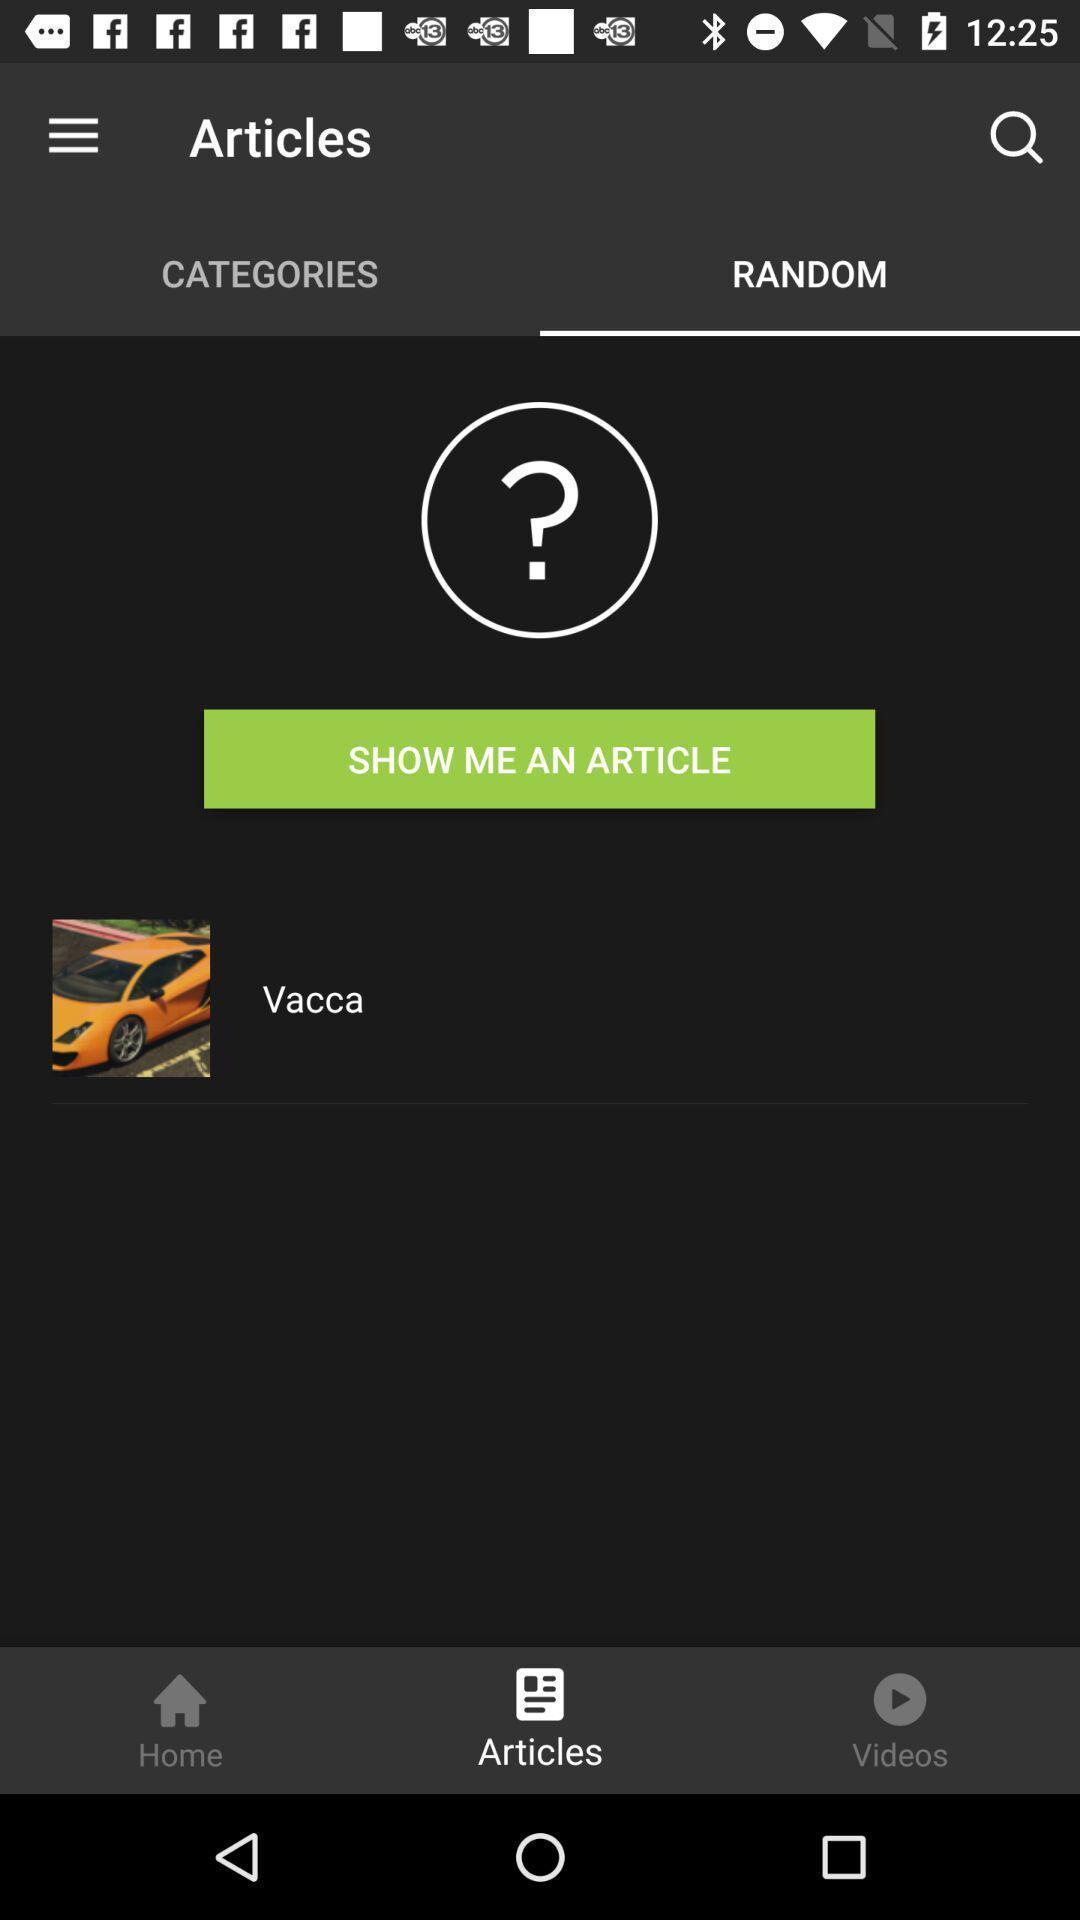Explain the elements present in this screenshot. Page showing different articles to read. 